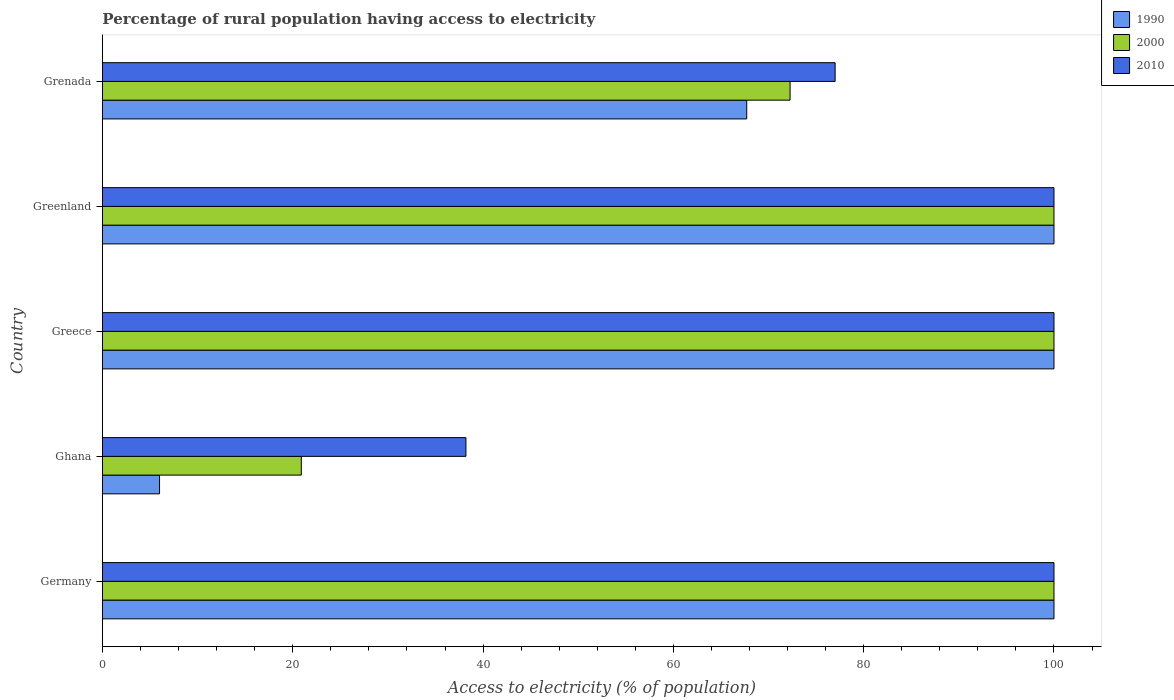How many groups of bars are there?
Provide a short and direct response. 5. Are the number of bars per tick equal to the number of legend labels?
Your response must be concise. Yes. Are the number of bars on each tick of the Y-axis equal?
Provide a short and direct response. Yes. How many bars are there on the 5th tick from the top?
Your answer should be compact. 3. What is the label of the 1st group of bars from the top?
Ensure brevity in your answer.  Grenada. In how many cases, is the number of bars for a given country not equal to the number of legend labels?
Keep it short and to the point. 0. What is the percentage of rural population having access to electricity in 2000 in Germany?
Offer a very short reply. 100. Across all countries, what is the maximum percentage of rural population having access to electricity in 2010?
Your answer should be compact. 100. Across all countries, what is the minimum percentage of rural population having access to electricity in 2000?
Give a very brief answer. 20.9. In which country was the percentage of rural population having access to electricity in 2010 minimum?
Offer a very short reply. Ghana. What is the total percentage of rural population having access to electricity in 1990 in the graph?
Give a very brief answer. 373.71. What is the difference between the percentage of rural population having access to electricity in 2000 in Germany and that in Greece?
Your response must be concise. 0. What is the difference between the percentage of rural population having access to electricity in 2010 in Greece and the percentage of rural population having access to electricity in 1990 in Ghana?
Your answer should be compact. 94. What is the average percentage of rural population having access to electricity in 2010 per country?
Your response must be concise. 83.04. What is the ratio of the percentage of rural population having access to electricity in 1990 in Greenland to that in Grenada?
Your response must be concise. 1.48. Is the difference between the percentage of rural population having access to electricity in 1990 in Germany and Ghana greater than the difference between the percentage of rural population having access to electricity in 2000 in Germany and Ghana?
Offer a terse response. Yes. What is the difference between the highest and the lowest percentage of rural population having access to electricity in 2000?
Offer a very short reply. 79.1. Is the sum of the percentage of rural population having access to electricity in 2010 in Germany and Ghana greater than the maximum percentage of rural population having access to electricity in 2000 across all countries?
Ensure brevity in your answer.  Yes. What does the 2nd bar from the top in Greenland represents?
Provide a succinct answer. 2000. What does the 1st bar from the bottom in Ghana represents?
Provide a short and direct response. 1990. Is it the case that in every country, the sum of the percentage of rural population having access to electricity in 2010 and percentage of rural population having access to electricity in 1990 is greater than the percentage of rural population having access to electricity in 2000?
Offer a very short reply. Yes. How many bars are there?
Your answer should be compact. 15. Are all the bars in the graph horizontal?
Give a very brief answer. Yes. How many countries are there in the graph?
Offer a terse response. 5. What is the difference between two consecutive major ticks on the X-axis?
Your response must be concise. 20. Are the values on the major ticks of X-axis written in scientific E-notation?
Provide a short and direct response. No. Does the graph contain any zero values?
Your answer should be very brief. No. How many legend labels are there?
Give a very brief answer. 3. How are the legend labels stacked?
Your answer should be very brief. Vertical. What is the title of the graph?
Your response must be concise. Percentage of rural population having access to electricity. What is the label or title of the X-axis?
Your answer should be compact. Access to electricity (% of population). What is the label or title of the Y-axis?
Your answer should be compact. Country. What is the Access to electricity (% of population) of 1990 in Germany?
Your answer should be very brief. 100. What is the Access to electricity (% of population) of 2010 in Germany?
Offer a very short reply. 100. What is the Access to electricity (% of population) of 2000 in Ghana?
Keep it short and to the point. 20.9. What is the Access to electricity (% of population) in 2010 in Ghana?
Make the answer very short. 38.2. What is the Access to electricity (% of population) of 2000 in Greece?
Provide a short and direct response. 100. What is the Access to electricity (% of population) of 1990 in Greenland?
Your response must be concise. 100. What is the Access to electricity (% of population) in 2010 in Greenland?
Provide a succinct answer. 100. What is the Access to electricity (% of population) in 1990 in Grenada?
Your answer should be very brief. 67.71. What is the Access to electricity (% of population) of 2000 in Grenada?
Offer a very short reply. 72.27. What is the Access to electricity (% of population) of 2010 in Grenada?
Keep it short and to the point. 77. Across all countries, what is the minimum Access to electricity (% of population) in 1990?
Your answer should be very brief. 6. Across all countries, what is the minimum Access to electricity (% of population) in 2000?
Ensure brevity in your answer.  20.9. Across all countries, what is the minimum Access to electricity (% of population) in 2010?
Provide a short and direct response. 38.2. What is the total Access to electricity (% of population) of 1990 in the graph?
Your response must be concise. 373.71. What is the total Access to electricity (% of population) in 2000 in the graph?
Ensure brevity in your answer.  393.17. What is the total Access to electricity (% of population) of 2010 in the graph?
Provide a short and direct response. 415.2. What is the difference between the Access to electricity (% of population) in 1990 in Germany and that in Ghana?
Offer a very short reply. 94. What is the difference between the Access to electricity (% of population) of 2000 in Germany and that in Ghana?
Make the answer very short. 79.1. What is the difference between the Access to electricity (% of population) of 2010 in Germany and that in Ghana?
Provide a short and direct response. 61.8. What is the difference between the Access to electricity (% of population) of 2000 in Germany and that in Greece?
Provide a succinct answer. 0. What is the difference between the Access to electricity (% of population) of 2010 in Germany and that in Greece?
Give a very brief answer. 0. What is the difference between the Access to electricity (% of population) of 1990 in Germany and that in Grenada?
Offer a very short reply. 32.29. What is the difference between the Access to electricity (% of population) of 2000 in Germany and that in Grenada?
Provide a short and direct response. 27.73. What is the difference between the Access to electricity (% of population) of 1990 in Ghana and that in Greece?
Offer a very short reply. -94. What is the difference between the Access to electricity (% of population) in 2000 in Ghana and that in Greece?
Provide a short and direct response. -79.1. What is the difference between the Access to electricity (% of population) in 2010 in Ghana and that in Greece?
Offer a very short reply. -61.8. What is the difference between the Access to electricity (% of population) of 1990 in Ghana and that in Greenland?
Keep it short and to the point. -94. What is the difference between the Access to electricity (% of population) of 2000 in Ghana and that in Greenland?
Offer a terse response. -79.1. What is the difference between the Access to electricity (% of population) of 2010 in Ghana and that in Greenland?
Give a very brief answer. -61.8. What is the difference between the Access to electricity (% of population) in 1990 in Ghana and that in Grenada?
Offer a very short reply. -61.71. What is the difference between the Access to electricity (% of population) in 2000 in Ghana and that in Grenada?
Your response must be concise. -51.37. What is the difference between the Access to electricity (% of population) of 2010 in Ghana and that in Grenada?
Your response must be concise. -38.8. What is the difference between the Access to electricity (% of population) in 1990 in Greece and that in Greenland?
Make the answer very short. 0. What is the difference between the Access to electricity (% of population) in 2010 in Greece and that in Greenland?
Offer a terse response. 0. What is the difference between the Access to electricity (% of population) of 1990 in Greece and that in Grenada?
Offer a terse response. 32.29. What is the difference between the Access to electricity (% of population) of 2000 in Greece and that in Grenada?
Provide a short and direct response. 27.73. What is the difference between the Access to electricity (% of population) in 2010 in Greece and that in Grenada?
Provide a succinct answer. 23. What is the difference between the Access to electricity (% of population) in 1990 in Greenland and that in Grenada?
Make the answer very short. 32.29. What is the difference between the Access to electricity (% of population) of 2000 in Greenland and that in Grenada?
Your answer should be compact. 27.73. What is the difference between the Access to electricity (% of population) of 1990 in Germany and the Access to electricity (% of population) of 2000 in Ghana?
Ensure brevity in your answer.  79.1. What is the difference between the Access to electricity (% of population) of 1990 in Germany and the Access to electricity (% of population) of 2010 in Ghana?
Ensure brevity in your answer.  61.8. What is the difference between the Access to electricity (% of population) of 2000 in Germany and the Access to electricity (% of population) of 2010 in Ghana?
Offer a terse response. 61.8. What is the difference between the Access to electricity (% of population) in 1990 in Germany and the Access to electricity (% of population) in 2010 in Greece?
Your answer should be compact. 0. What is the difference between the Access to electricity (% of population) of 2000 in Germany and the Access to electricity (% of population) of 2010 in Greece?
Offer a very short reply. 0. What is the difference between the Access to electricity (% of population) in 1990 in Germany and the Access to electricity (% of population) in 2000 in Greenland?
Make the answer very short. 0. What is the difference between the Access to electricity (% of population) of 1990 in Germany and the Access to electricity (% of population) of 2000 in Grenada?
Ensure brevity in your answer.  27.73. What is the difference between the Access to electricity (% of population) of 1990 in Germany and the Access to electricity (% of population) of 2010 in Grenada?
Provide a short and direct response. 23. What is the difference between the Access to electricity (% of population) in 1990 in Ghana and the Access to electricity (% of population) in 2000 in Greece?
Offer a terse response. -94. What is the difference between the Access to electricity (% of population) in 1990 in Ghana and the Access to electricity (% of population) in 2010 in Greece?
Ensure brevity in your answer.  -94. What is the difference between the Access to electricity (% of population) in 2000 in Ghana and the Access to electricity (% of population) in 2010 in Greece?
Your answer should be very brief. -79.1. What is the difference between the Access to electricity (% of population) in 1990 in Ghana and the Access to electricity (% of population) in 2000 in Greenland?
Your answer should be very brief. -94. What is the difference between the Access to electricity (% of population) in 1990 in Ghana and the Access to electricity (% of population) in 2010 in Greenland?
Provide a short and direct response. -94. What is the difference between the Access to electricity (% of population) in 2000 in Ghana and the Access to electricity (% of population) in 2010 in Greenland?
Ensure brevity in your answer.  -79.1. What is the difference between the Access to electricity (% of population) in 1990 in Ghana and the Access to electricity (% of population) in 2000 in Grenada?
Provide a short and direct response. -66.27. What is the difference between the Access to electricity (% of population) of 1990 in Ghana and the Access to electricity (% of population) of 2010 in Grenada?
Offer a terse response. -71. What is the difference between the Access to electricity (% of population) of 2000 in Ghana and the Access to electricity (% of population) of 2010 in Grenada?
Make the answer very short. -56.1. What is the difference between the Access to electricity (% of population) of 2000 in Greece and the Access to electricity (% of population) of 2010 in Greenland?
Make the answer very short. 0. What is the difference between the Access to electricity (% of population) in 1990 in Greece and the Access to electricity (% of population) in 2000 in Grenada?
Your answer should be very brief. 27.73. What is the difference between the Access to electricity (% of population) of 1990 in Greenland and the Access to electricity (% of population) of 2000 in Grenada?
Provide a succinct answer. 27.73. What is the difference between the Access to electricity (% of population) in 1990 in Greenland and the Access to electricity (% of population) in 2010 in Grenada?
Give a very brief answer. 23. What is the difference between the Access to electricity (% of population) in 2000 in Greenland and the Access to electricity (% of population) in 2010 in Grenada?
Ensure brevity in your answer.  23. What is the average Access to electricity (% of population) in 1990 per country?
Your answer should be compact. 74.74. What is the average Access to electricity (% of population) of 2000 per country?
Keep it short and to the point. 78.63. What is the average Access to electricity (% of population) of 2010 per country?
Give a very brief answer. 83.04. What is the difference between the Access to electricity (% of population) of 1990 and Access to electricity (% of population) of 2010 in Germany?
Your answer should be compact. 0. What is the difference between the Access to electricity (% of population) of 2000 and Access to electricity (% of population) of 2010 in Germany?
Your answer should be compact. 0. What is the difference between the Access to electricity (% of population) of 1990 and Access to electricity (% of population) of 2000 in Ghana?
Your answer should be very brief. -14.9. What is the difference between the Access to electricity (% of population) of 1990 and Access to electricity (% of population) of 2010 in Ghana?
Provide a succinct answer. -32.2. What is the difference between the Access to electricity (% of population) of 2000 and Access to electricity (% of population) of 2010 in Ghana?
Your answer should be very brief. -17.3. What is the difference between the Access to electricity (% of population) of 1990 and Access to electricity (% of population) of 2010 in Greece?
Keep it short and to the point. 0. What is the difference between the Access to electricity (% of population) of 1990 and Access to electricity (% of population) of 2010 in Greenland?
Offer a very short reply. 0. What is the difference between the Access to electricity (% of population) of 1990 and Access to electricity (% of population) of 2000 in Grenada?
Offer a very short reply. -4.55. What is the difference between the Access to electricity (% of population) of 1990 and Access to electricity (% of population) of 2010 in Grenada?
Provide a succinct answer. -9.29. What is the difference between the Access to electricity (% of population) in 2000 and Access to electricity (% of population) in 2010 in Grenada?
Ensure brevity in your answer.  -4.74. What is the ratio of the Access to electricity (% of population) in 1990 in Germany to that in Ghana?
Offer a very short reply. 16.67. What is the ratio of the Access to electricity (% of population) in 2000 in Germany to that in Ghana?
Give a very brief answer. 4.78. What is the ratio of the Access to electricity (% of population) in 2010 in Germany to that in Ghana?
Ensure brevity in your answer.  2.62. What is the ratio of the Access to electricity (% of population) of 1990 in Germany to that in Greece?
Offer a very short reply. 1. What is the ratio of the Access to electricity (% of population) of 2000 in Germany to that in Greenland?
Give a very brief answer. 1. What is the ratio of the Access to electricity (% of population) of 1990 in Germany to that in Grenada?
Provide a short and direct response. 1.48. What is the ratio of the Access to electricity (% of population) in 2000 in Germany to that in Grenada?
Offer a terse response. 1.38. What is the ratio of the Access to electricity (% of population) in 2010 in Germany to that in Grenada?
Make the answer very short. 1.3. What is the ratio of the Access to electricity (% of population) in 2000 in Ghana to that in Greece?
Your response must be concise. 0.21. What is the ratio of the Access to electricity (% of population) of 2010 in Ghana to that in Greece?
Make the answer very short. 0.38. What is the ratio of the Access to electricity (% of population) of 2000 in Ghana to that in Greenland?
Provide a short and direct response. 0.21. What is the ratio of the Access to electricity (% of population) of 2010 in Ghana to that in Greenland?
Provide a succinct answer. 0.38. What is the ratio of the Access to electricity (% of population) of 1990 in Ghana to that in Grenada?
Provide a succinct answer. 0.09. What is the ratio of the Access to electricity (% of population) of 2000 in Ghana to that in Grenada?
Give a very brief answer. 0.29. What is the ratio of the Access to electricity (% of population) of 2010 in Ghana to that in Grenada?
Ensure brevity in your answer.  0.5. What is the ratio of the Access to electricity (% of population) in 1990 in Greece to that in Greenland?
Offer a terse response. 1. What is the ratio of the Access to electricity (% of population) in 1990 in Greece to that in Grenada?
Provide a succinct answer. 1.48. What is the ratio of the Access to electricity (% of population) of 2000 in Greece to that in Grenada?
Keep it short and to the point. 1.38. What is the ratio of the Access to electricity (% of population) of 2010 in Greece to that in Grenada?
Keep it short and to the point. 1.3. What is the ratio of the Access to electricity (% of population) in 1990 in Greenland to that in Grenada?
Offer a very short reply. 1.48. What is the ratio of the Access to electricity (% of population) of 2000 in Greenland to that in Grenada?
Your response must be concise. 1.38. What is the ratio of the Access to electricity (% of population) of 2010 in Greenland to that in Grenada?
Keep it short and to the point. 1.3. What is the difference between the highest and the second highest Access to electricity (% of population) in 1990?
Ensure brevity in your answer.  0. What is the difference between the highest and the second highest Access to electricity (% of population) in 2000?
Ensure brevity in your answer.  0. What is the difference between the highest and the lowest Access to electricity (% of population) of 1990?
Offer a terse response. 94. What is the difference between the highest and the lowest Access to electricity (% of population) of 2000?
Give a very brief answer. 79.1. What is the difference between the highest and the lowest Access to electricity (% of population) in 2010?
Make the answer very short. 61.8. 